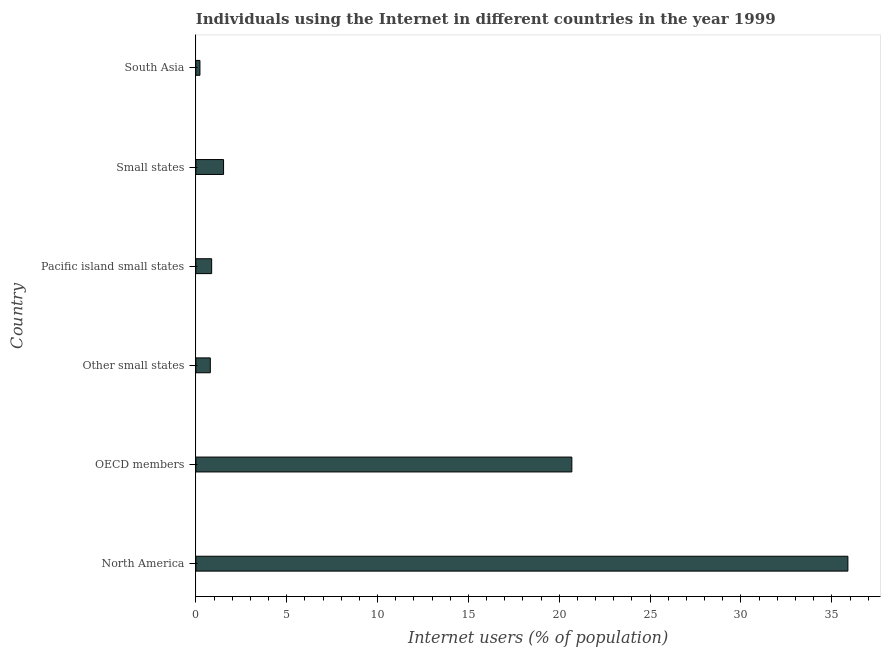Does the graph contain grids?
Keep it short and to the point. No. What is the title of the graph?
Make the answer very short. Individuals using the Internet in different countries in the year 1999. What is the label or title of the X-axis?
Ensure brevity in your answer.  Internet users (% of population). What is the label or title of the Y-axis?
Provide a short and direct response. Country. What is the number of internet users in North America?
Make the answer very short. 35.88. Across all countries, what is the maximum number of internet users?
Ensure brevity in your answer.  35.88. Across all countries, what is the minimum number of internet users?
Provide a short and direct response. 0.23. What is the sum of the number of internet users?
Your answer should be compact. 59.99. What is the difference between the number of internet users in Other small states and Small states?
Offer a terse response. -0.73. What is the average number of internet users per country?
Make the answer very short. 10. What is the median number of internet users?
Offer a terse response. 1.2. In how many countries, is the number of internet users greater than 30 %?
Provide a succinct answer. 1. What is the ratio of the number of internet users in Other small states to that in South Asia?
Ensure brevity in your answer.  3.52. What is the difference between the highest and the second highest number of internet users?
Make the answer very short. 15.19. What is the difference between the highest and the lowest number of internet users?
Your answer should be very brief. 35.66. In how many countries, is the number of internet users greater than the average number of internet users taken over all countries?
Make the answer very short. 2. How many bars are there?
Offer a very short reply. 6. How many countries are there in the graph?
Your answer should be very brief. 6. Are the values on the major ticks of X-axis written in scientific E-notation?
Provide a succinct answer. No. What is the Internet users (% of population) of North America?
Provide a succinct answer. 35.88. What is the Internet users (% of population) in OECD members?
Your answer should be compact. 20.69. What is the Internet users (% of population) in Other small states?
Make the answer very short. 0.8. What is the Internet users (% of population) of Pacific island small states?
Offer a very short reply. 0.87. What is the Internet users (% of population) of Small states?
Your response must be concise. 1.53. What is the Internet users (% of population) of South Asia?
Provide a short and direct response. 0.23. What is the difference between the Internet users (% of population) in North America and OECD members?
Your answer should be compact. 15.19. What is the difference between the Internet users (% of population) in North America and Other small states?
Offer a terse response. 35.09. What is the difference between the Internet users (% of population) in North America and Pacific island small states?
Give a very brief answer. 35.01. What is the difference between the Internet users (% of population) in North America and Small states?
Provide a short and direct response. 34.36. What is the difference between the Internet users (% of population) in North America and South Asia?
Make the answer very short. 35.66. What is the difference between the Internet users (% of population) in OECD members and Other small states?
Offer a very short reply. 19.89. What is the difference between the Internet users (% of population) in OECD members and Pacific island small states?
Your answer should be compact. 19.82. What is the difference between the Internet users (% of population) in OECD members and Small states?
Your answer should be compact. 19.16. What is the difference between the Internet users (% of population) in OECD members and South Asia?
Make the answer very short. 20.47. What is the difference between the Internet users (% of population) in Other small states and Pacific island small states?
Your response must be concise. -0.07. What is the difference between the Internet users (% of population) in Other small states and Small states?
Provide a succinct answer. -0.73. What is the difference between the Internet users (% of population) in Other small states and South Asia?
Your answer should be compact. 0.57. What is the difference between the Internet users (% of population) in Pacific island small states and Small states?
Give a very brief answer. -0.66. What is the difference between the Internet users (% of population) in Pacific island small states and South Asia?
Give a very brief answer. 0.64. What is the difference between the Internet users (% of population) in Small states and South Asia?
Give a very brief answer. 1.3. What is the ratio of the Internet users (% of population) in North America to that in OECD members?
Make the answer very short. 1.73. What is the ratio of the Internet users (% of population) in North America to that in Other small states?
Your response must be concise. 45. What is the ratio of the Internet users (% of population) in North America to that in Pacific island small states?
Keep it short and to the point. 41.22. What is the ratio of the Internet users (% of population) in North America to that in Small states?
Your answer should be very brief. 23.5. What is the ratio of the Internet users (% of population) in North America to that in South Asia?
Your answer should be very brief. 158.55. What is the ratio of the Internet users (% of population) in OECD members to that in Other small states?
Ensure brevity in your answer.  25.95. What is the ratio of the Internet users (% of population) in OECD members to that in Pacific island small states?
Offer a terse response. 23.77. What is the ratio of the Internet users (% of population) in OECD members to that in Small states?
Your answer should be compact. 13.55. What is the ratio of the Internet users (% of population) in OECD members to that in South Asia?
Give a very brief answer. 91.43. What is the ratio of the Internet users (% of population) in Other small states to that in Pacific island small states?
Offer a terse response. 0.92. What is the ratio of the Internet users (% of population) in Other small states to that in Small states?
Offer a terse response. 0.52. What is the ratio of the Internet users (% of population) in Other small states to that in South Asia?
Your answer should be compact. 3.52. What is the ratio of the Internet users (% of population) in Pacific island small states to that in Small states?
Provide a short and direct response. 0.57. What is the ratio of the Internet users (% of population) in Pacific island small states to that in South Asia?
Your answer should be compact. 3.85. What is the ratio of the Internet users (% of population) in Small states to that in South Asia?
Make the answer very short. 6.75. 